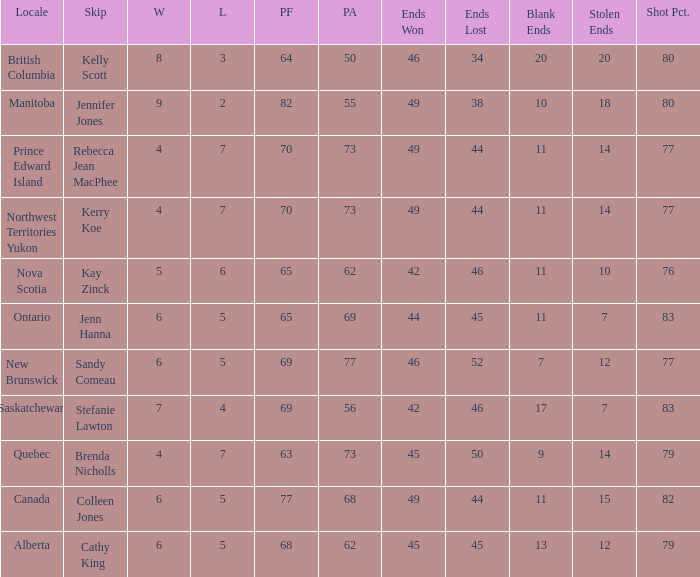What is the total number of ends won when the locale is Northwest Territories Yukon? 1.0. 